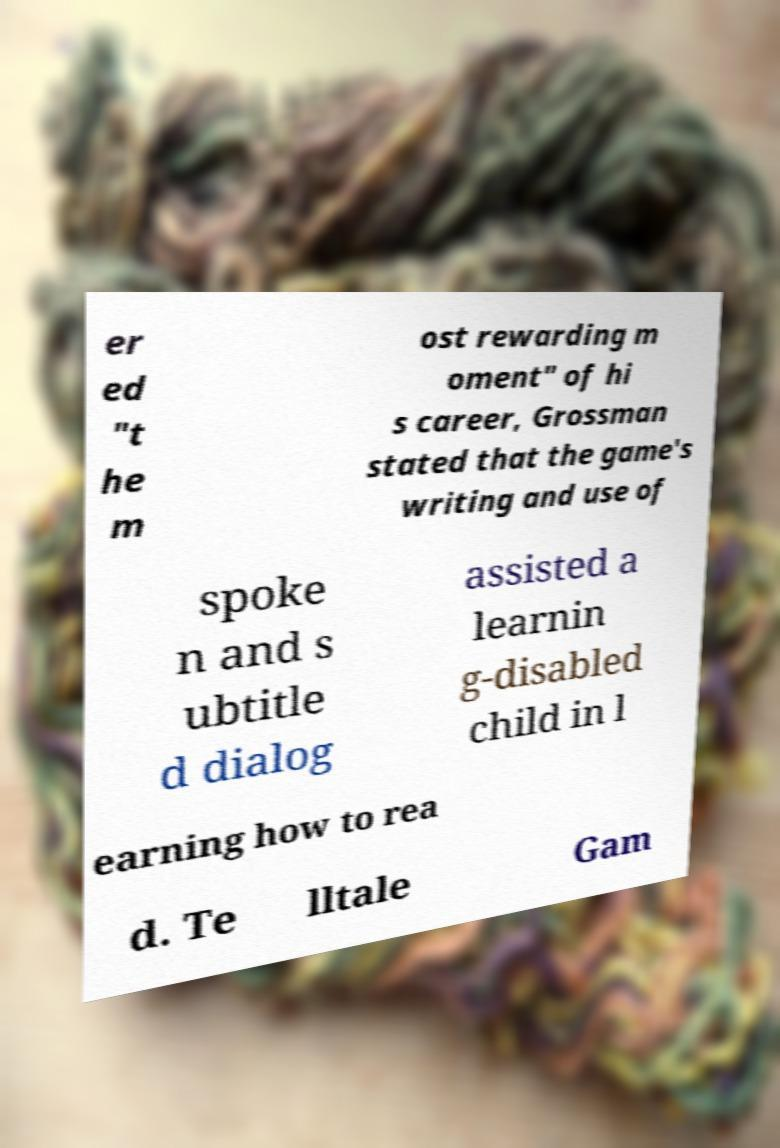Can you accurately transcribe the text from the provided image for me? er ed "t he m ost rewarding m oment" of hi s career, Grossman stated that the game's writing and use of spoke n and s ubtitle d dialog assisted a learnin g-disabled child in l earning how to rea d. Te lltale Gam 